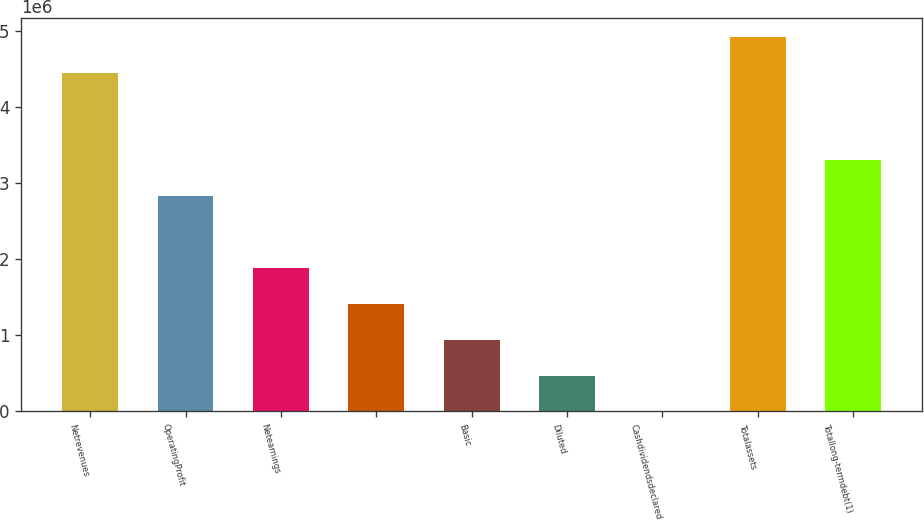Convert chart to OTSL. <chart><loc_0><loc_0><loc_500><loc_500><bar_chart><fcel>Netrevenues<fcel>OperatingProfit<fcel>Netearnings<fcel>Unnamed: 3<fcel>Basic<fcel>Diluted<fcel>Cashdividendsdeclared<fcel>Totalassets<fcel>Totallong-termdebt(1)<nl><fcel>4.44751e+06<fcel>2.83243e+06<fcel>1.88829e+06<fcel>1.41622e+06<fcel>944145<fcel>472073<fcel>1.84<fcel>4.91958e+06<fcel>3.3045e+06<nl></chart> 